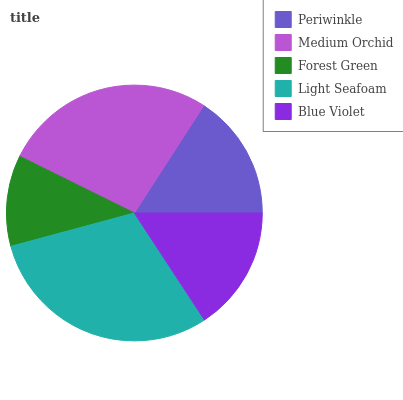Is Forest Green the minimum?
Answer yes or no. Yes. Is Light Seafoam the maximum?
Answer yes or no. Yes. Is Medium Orchid the minimum?
Answer yes or no. No. Is Medium Orchid the maximum?
Answer yes or no. No. Is Medium Orchid greater than Periwinkle?
Answer yes or no. Yes. Is Periwinkle less than Medium Orchid?
Answer yes or no. Yes. Is Periwinkle greater than Medium Orchid?
Answer yes or no. No. Is Medium Orchid less than Periwinkle?
Answer yes or no. No. Is Periwinkle the high median?
Answer yes or no. Yes. Is Periwinkle the low median?
Answer yes or no. Yes. Is Forest Green the high median?
Answer yes or no. No. Is Blue Violet the low median?
Answer yes or no. No. 